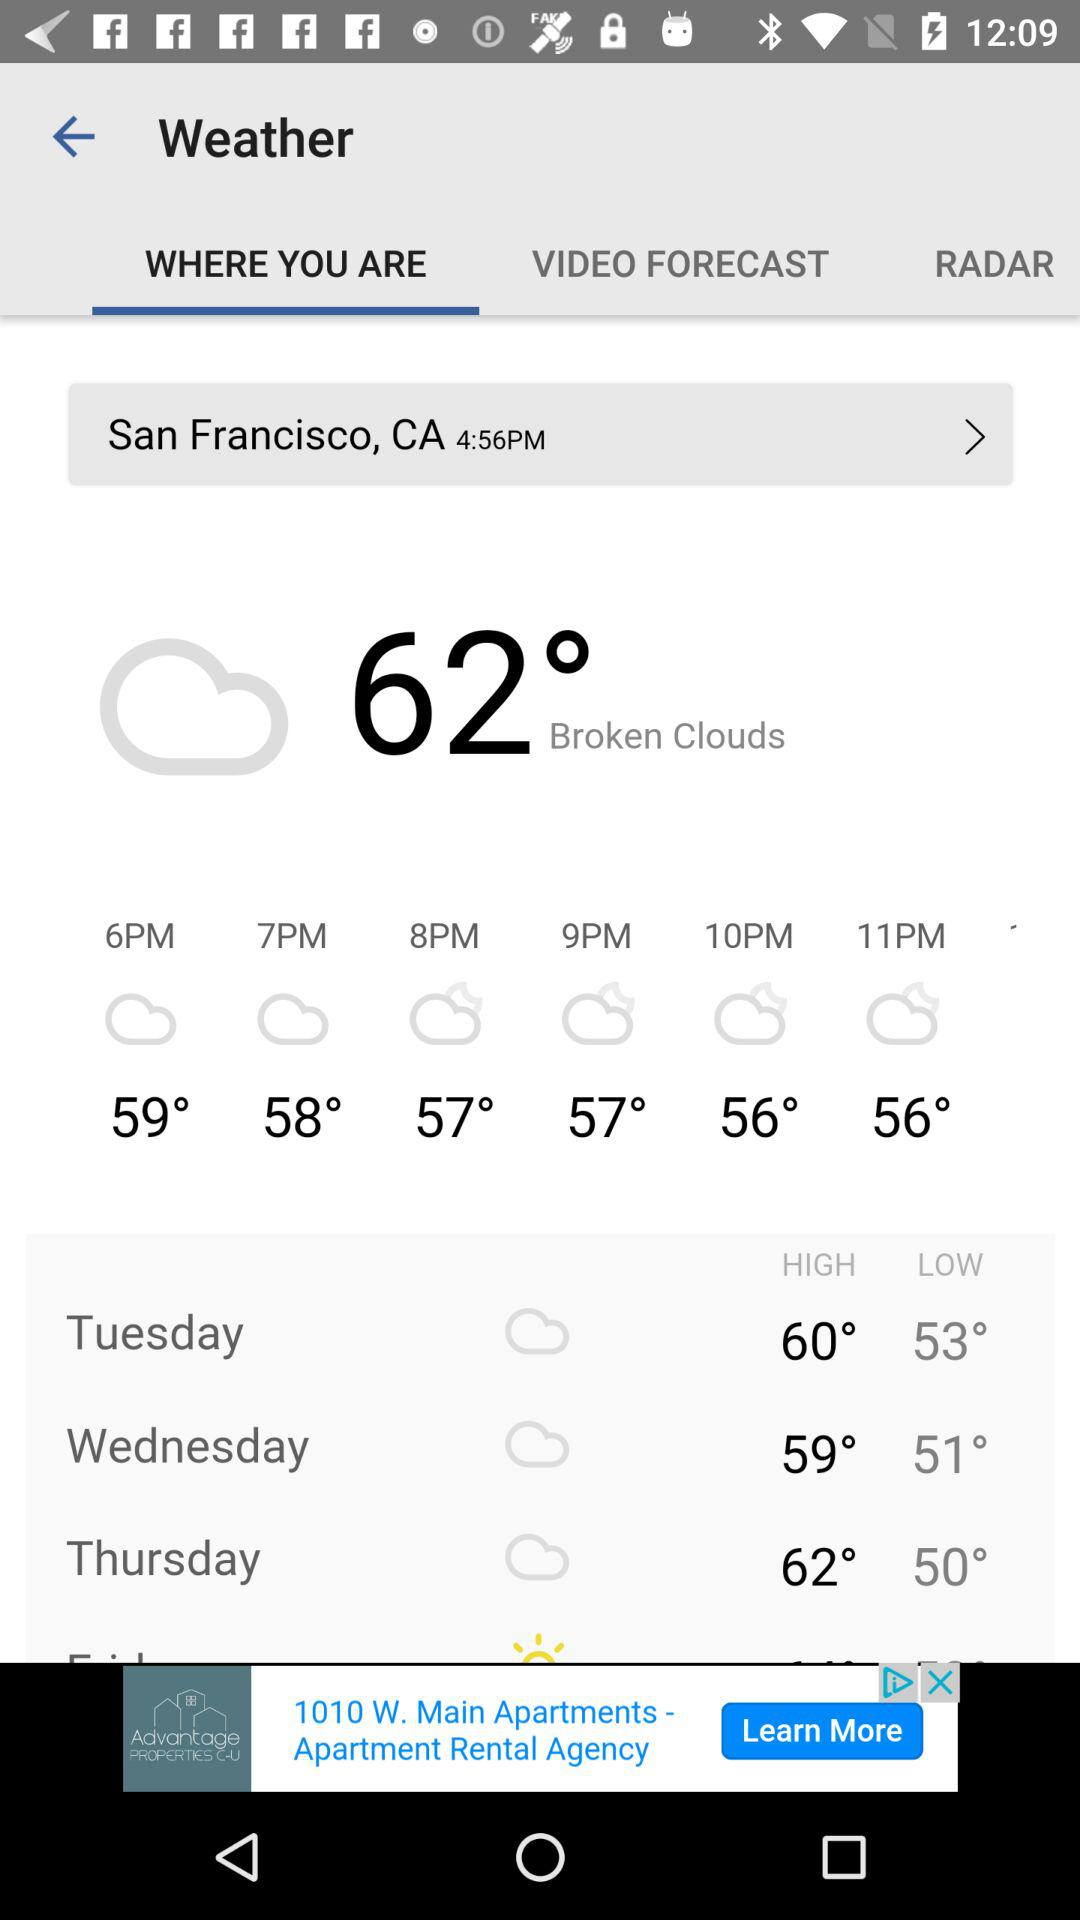Which tab is selected? The selected tab is "WHERE YOU ARE". 